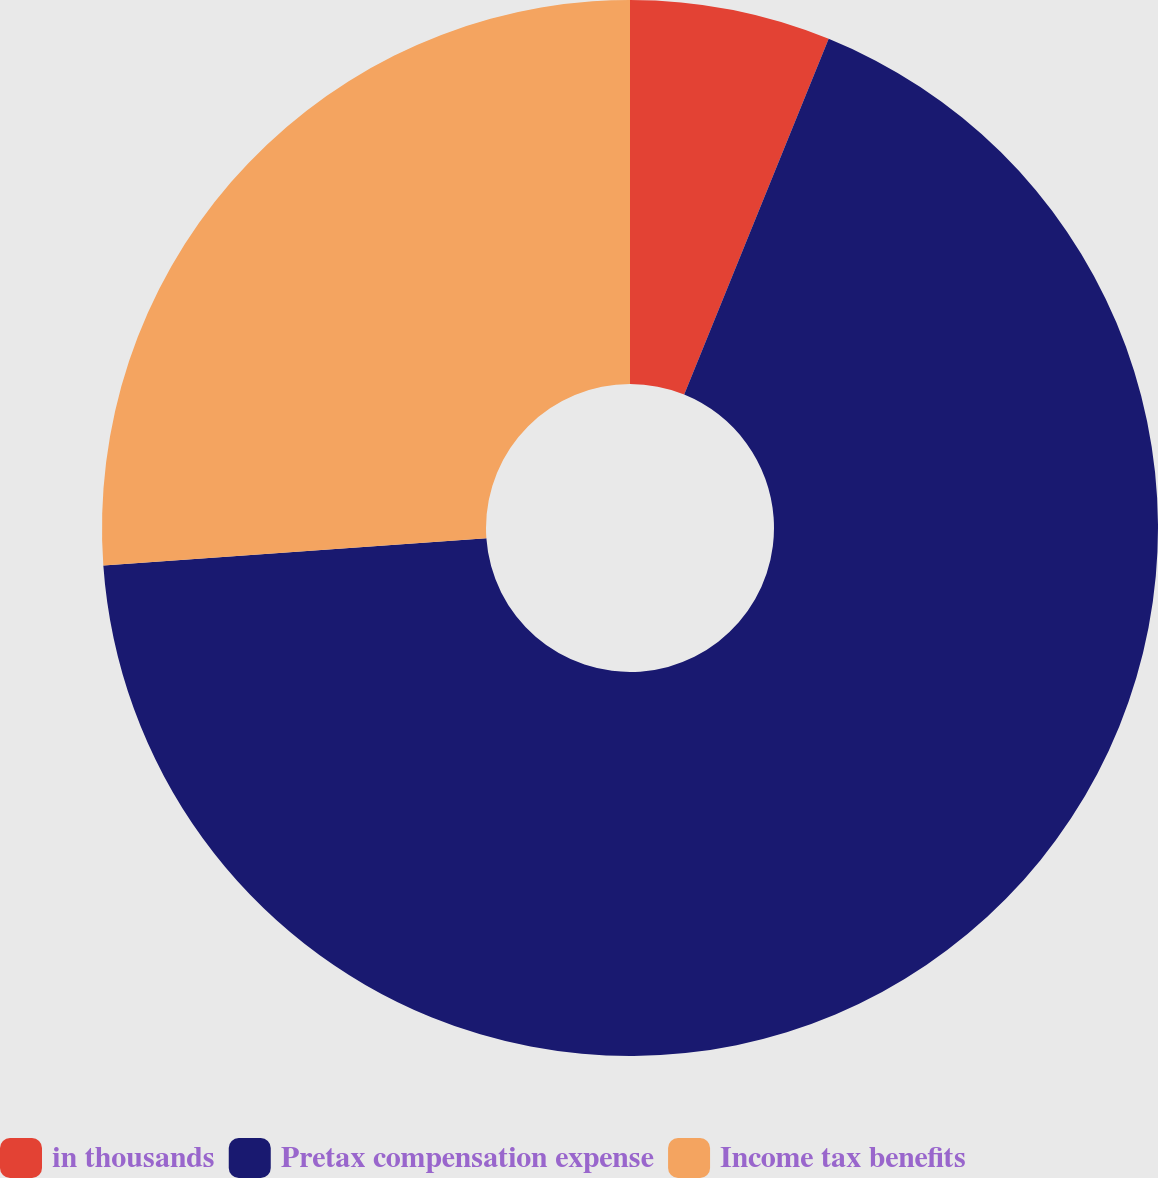<chart> <loc_0><loc_0><loc_500><loc_500><pie_chart><fcel>in thousands<fcel>Pretax compensation expense<fcel>Income tax benefits<nl><fcel>6.14%<fcel>67.73%<fcel>26.13%<nl></chart> 